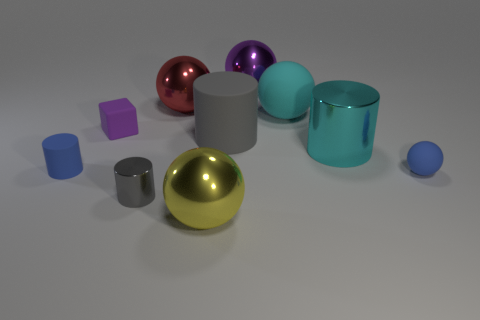There is a thing that is the same color as the tiny block; what is its shape?
Your response must be concise. Sphere. Are there any matte things of the same color as the tiny metal object?
Ensure brevity in your answer.  Yes. There is a object that is the same color as the large rubber sphere; what is its size?
Ensure brevity in your answer.  Large. Are there fewer large rubber things that are on the left side of the yellow shiny object than yellow metal objects on the right side of the large gray thing?
Your response must be concise. No. What is the color of the ball that is in front of the tiny matte cylinder and on the right side of the yellow object?
Offer a terse response. Blue. Is the size of the yellow shiny ball the same as the blue rubber thing left of the gray shiny cylinder?
Offer a very short reply. No. There is a gray thing left of the large gray rubber cylinder; what is its shape?
Give a very brief answer. Cylinder. Is the number of rubber objects that are to the left of the tiny purple matte block greater than the number of tiny yellow metal cylinders?
Your answer should be very brief. Yes. What number of rubber spheres are behind the tiny blue rubber thing that is in front of the tiny blue thing that is to the left of the large purple sphere?
Provide a succinct answer. 1. There is a shiny cylinder that is on the right side of the purple metallic ball; does it have the same size as the blue object that is on the right side of the big purple thing?
Ensure brevity in your answer.  No. 